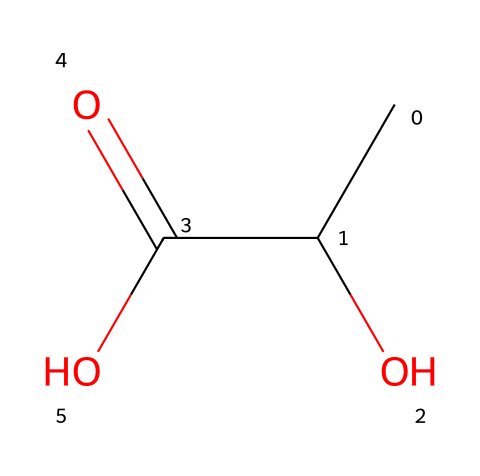What is the name of this chemical? The SMILES representation corresponds to a molecule with the functional groups characteristic of an acid, specifically a carboxylic acid. Based on the structure indicated by the SMILES (CC(O)C(=O)O), this compound is identified as lactic acid, which is well known in food fermentation.
Answer: lactic acid How many carbon atoms are in this molecule? Analyzing the SMILES representation, we see "CC" at the start, indicating two carbon atoms. The "C" in "C(O)" indicates another carbon atom connected to the hydroxyl group. Therefore, the total number of carbon atoms is three.
Answer: three Is this compound a strong or weak acid? To determine if this acid is strong or weak, we consider its ability to dissociate in water. Lactic acid is known to only partially dissociate, indicating it is a weak acid.
Answer: weak What functional group characterizes this acid? The presence of the "-COOH" group in the structure, as seen in the C(=O)O part of the SMILES, indicates the functional group characteristic of carboxylic acids. This is typical for lactic acid and defines its acidic properties.
Answer: carboxylic acid What effect does lactic acid production have on gut health? Lactic acid, a byproduct of fermentation, is known to promote gut health by providing an acidic environment that supports the growth of beneficial bacteria and inhibits harmful pathogens. Thus, the overall effect is beneficial.
Answer: beneficial 